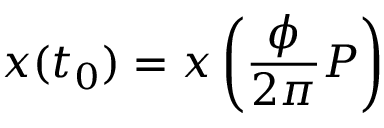<formula> <loc_0><loc_0><loc_500><loc_500>x ( t _ { 0 } ) = x \left ( \frac { \phi } { 2 \pi } P \right )</formula> 